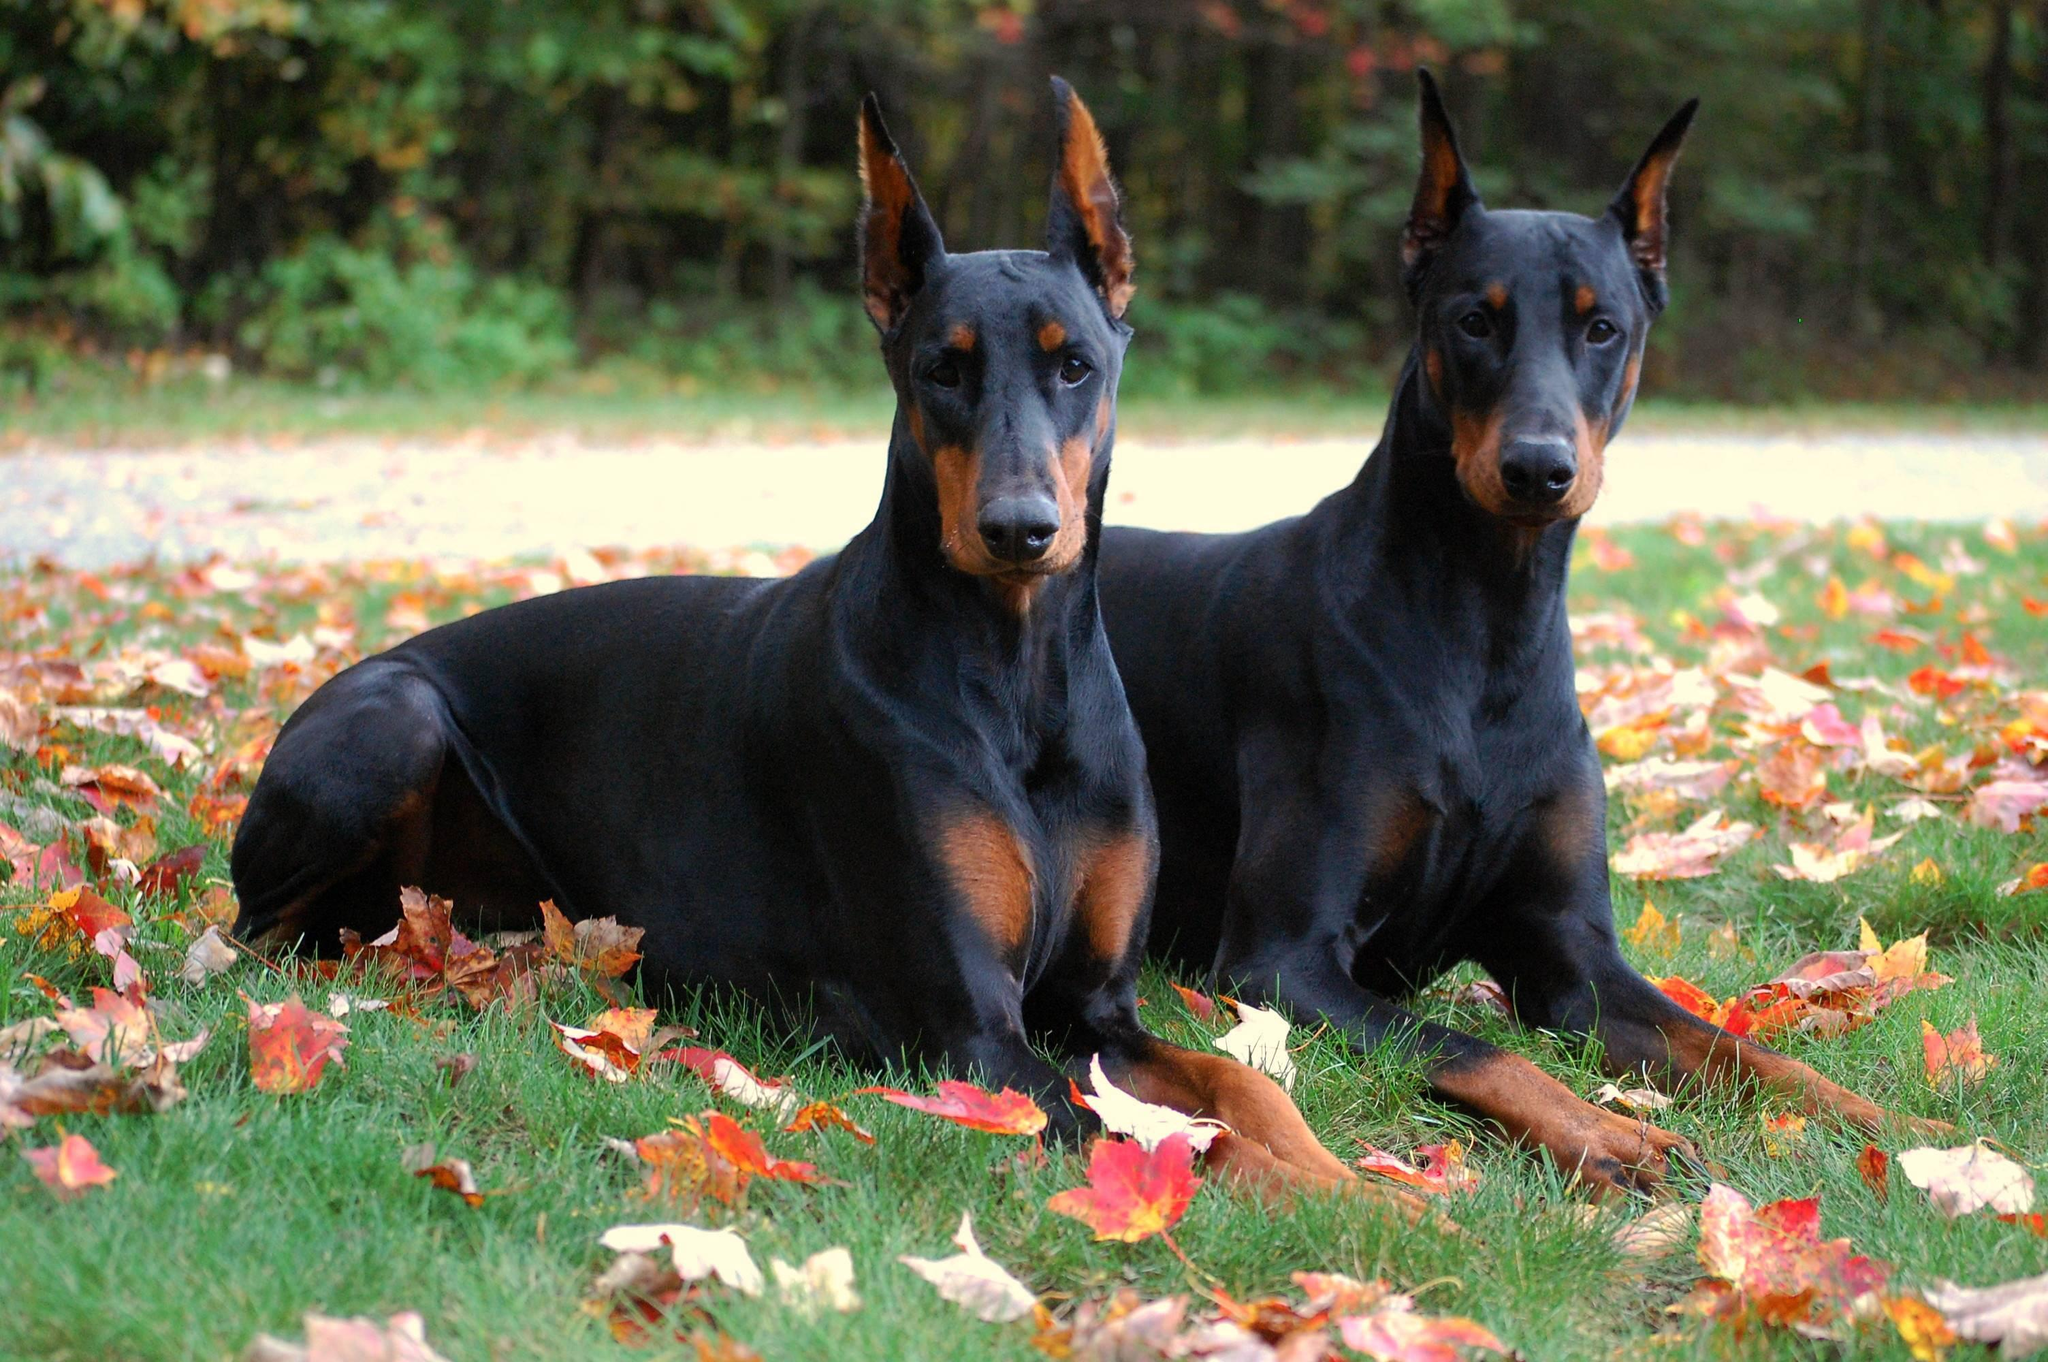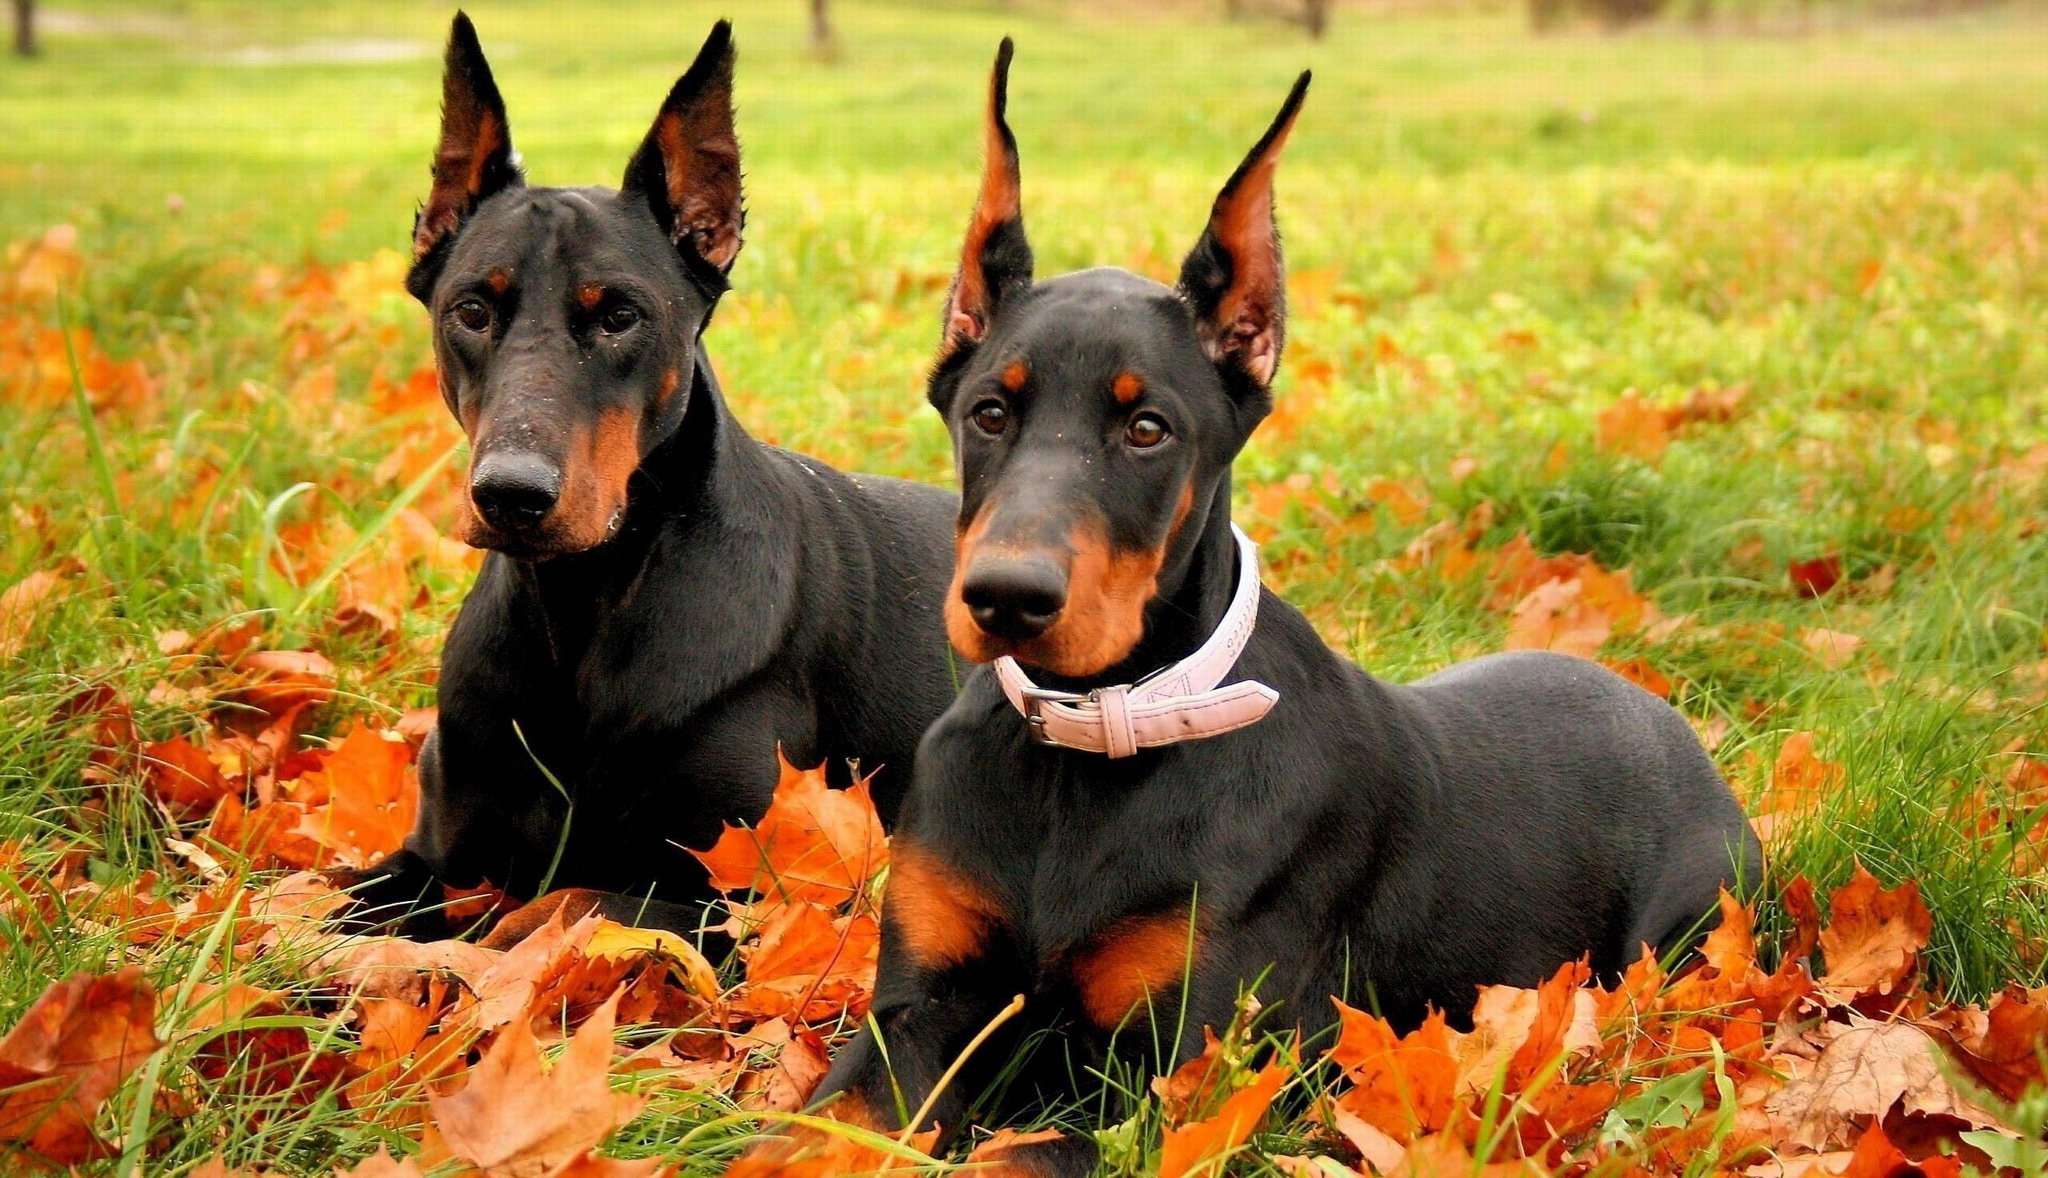The first image is the image on the left, the second image is the image on the right. Evaluate the accuracy of this statement regarding the images: "The right image contains exactly two dogs.". Is it true? Answer yes or no. Yes. The first image is the image on the left, the second image is the image on the right. Examine the images to the left and right. Is the description "A minimum of 3 dogs are present" accurate? Answer yes or no. Yes. 